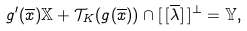<formula> <loc_0><loc_0><loc_500><loc_500>g ^ { \prime } ( \overline { x } ) \mathbb { X } + \mathcal { T } _ { K } ( g ( \overline { x } ) ) \cap [ \, [ \overline { \lambda } ] \, ] ^ { \perp } = \mathbb { Y } ,</formula> 